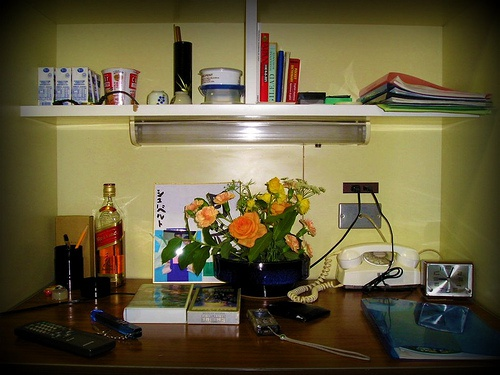Describe the objects in this image and their specific colors. I can see potted plant in black, olive, and darkgreen tones, book in black, gray, darkgreen, and teal tones, vase in black, navy, gray, and olive tones, bottle in black, maroon, and olive tones, and book in black, darkgray, olive, and gray tones in this image. 